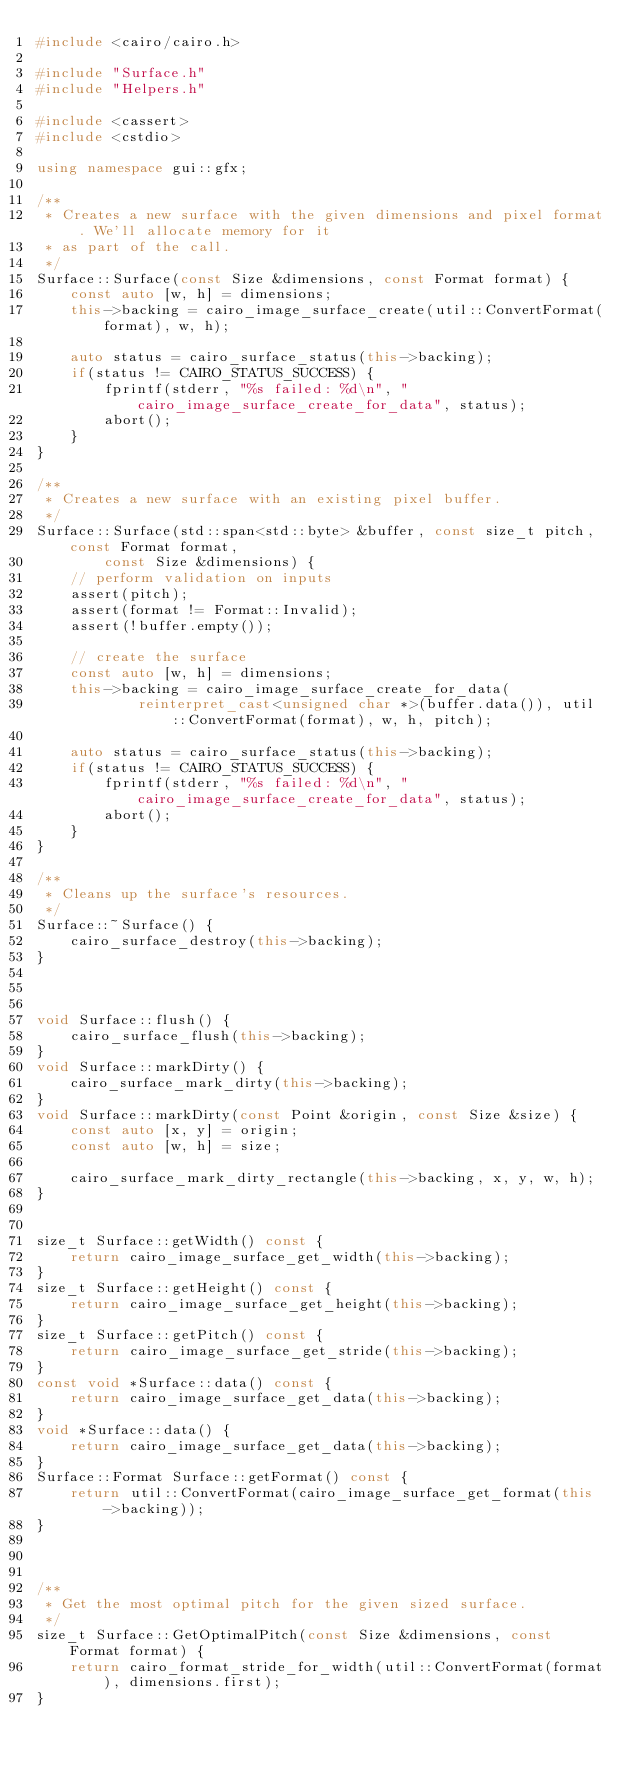<code> <loc_0><loc_0><loc_500><loc_500><_C++_>#include <cairo/cairo.h>

#include "Surface.h"
#include "Helpers.h"

#include <cassert>
#include <cstdio>

using namespace gui::gfx;

/**
 * Creates a new surface with the given dimensions and pixel format. We'll allocate memory for it
 * as part of the call.
 */
Surface::Surface(const Size &dimensions, const Format format) {
    const auto [w, h] = dimensions;
    this->backing = cairo_image_surface_create(util::ConvertFormat(format), w, h);

    auto status = cairo_surface_status(this->backing);
    if(status != CAIRO_STATUS_SUCCESS) {
        fprintf(stderr, "%s failed: %d\n", "cairo_image_surface_create_for_data", status);
        abort();
    }
}

/**
 * Creates a new surface with an existing pixel buffer.
 */
Surface::Surface(std::span<std::byte> &buffer, const size_t pitch, const Format format,
        const Size &dimensions) {
    // perform validation on inputs
    assert(pitch);
    assert(format != Format::Invalid);
    assert(!buffer.empty());

    // create the surface
    const auto [w, h] = dimensions;
    this->backing = cairo_image_surface_create_for_data(
            reinterpret_cast<unsigned char *>(buffer.data()), util::ConvertFormat(format), w, h, pitch);

    auto status = cairo_surface_status(this->backing);
    if(status != CAIRO_STATUS_SUCCESS) {
        fprintf(stderr, "%s failed: %d\n", "cairo_image_surface_create_for_data", status);
        abort();
    }
}

/**
 * Cleans up the surface's resources.
 */
Surface::~Surface() {
    cairo_surface_destroy(this->backing);
}



void Surface::flush() {
    cairo_surface_flush(this->backing);
}
void Surface::markDirty() {
    cairo_surface_mark_dirty(this->backing);
}
void Surface::markDirty(const Point &origin, const Size &size) {
    const auto [x, y] = origin;
    const auto [w, h] = size;

    cairo_surface_mark_dirty_rectangle(this->backing, x, y, w, h);
}


size_t Surface::getWidth() const {
    return cairo_image_surface_get_width(this->backing);
}
size_t Surface::getHeight() const {
    return cairo_image_surface_get_height(this->backing);
}
size_t Surface::getPitch() const {
    return cairo_image_surface_get_stride(this->backing);
}
const void *Surface::data() const {
    return cairo_image_surface_get_data(this->backing);
}
void *Surface::data() {
    return cairo_image_surface_get_data(this->backing);
}
Surface::Format Surface::getFormat() const {
    return util::ConvertFormat(cairo_image_surface_get_format(this->backing));
}



/**
 * Get the most optimal pitch for the given sized surface.
 */
size_t Surface::GetOptimalPitch(const Size &dimensions, const Format format) {
    return cairo_format_stride_for_width(util::ConvertFormat(format), dimensions.first);
}

</code> 